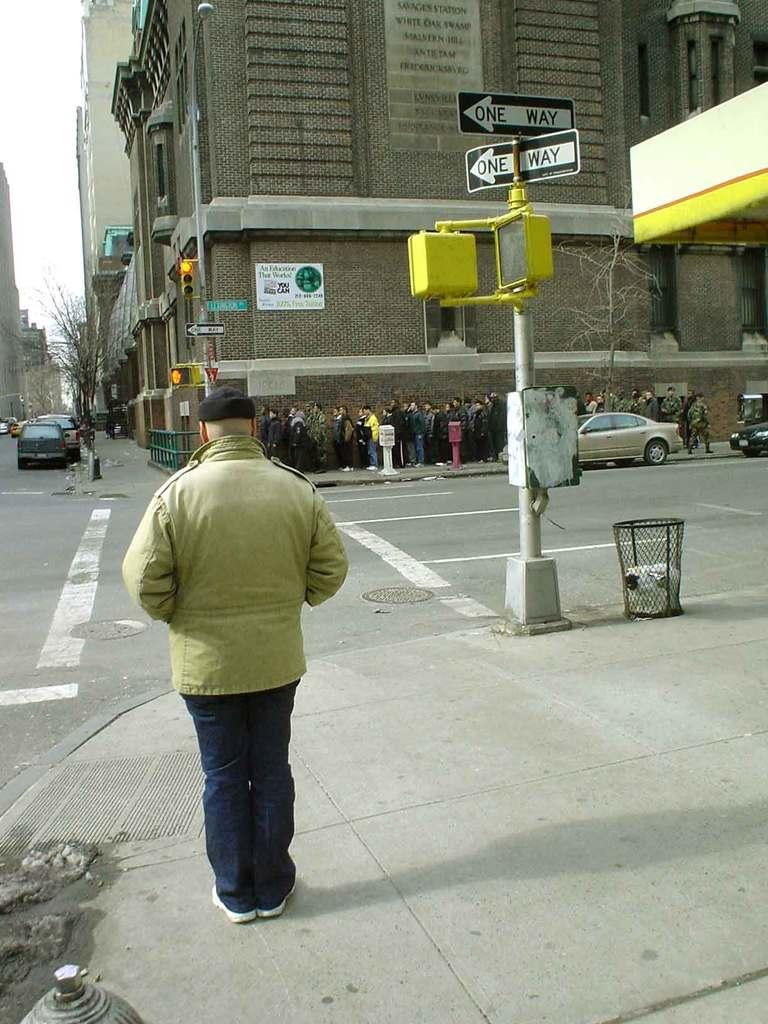What are the people in the image doing? The persons in the image are standing on the road. What structures can be seen in the image? There are buildings, traffic poles, and sign boards visible in the image. What type of transportation is present on the road? Motor vehicles are on the road in the image. What objects are used for waste disposal in the image? Trash bins are in the image. What can be seen in the sky in the image? The sky is visible in the image. What is the weight of the frame in the image? There is no frame present in the image, so it is not possible to determine its weight. What type of record is being played in the image? There is no record player or music playing in the image. 